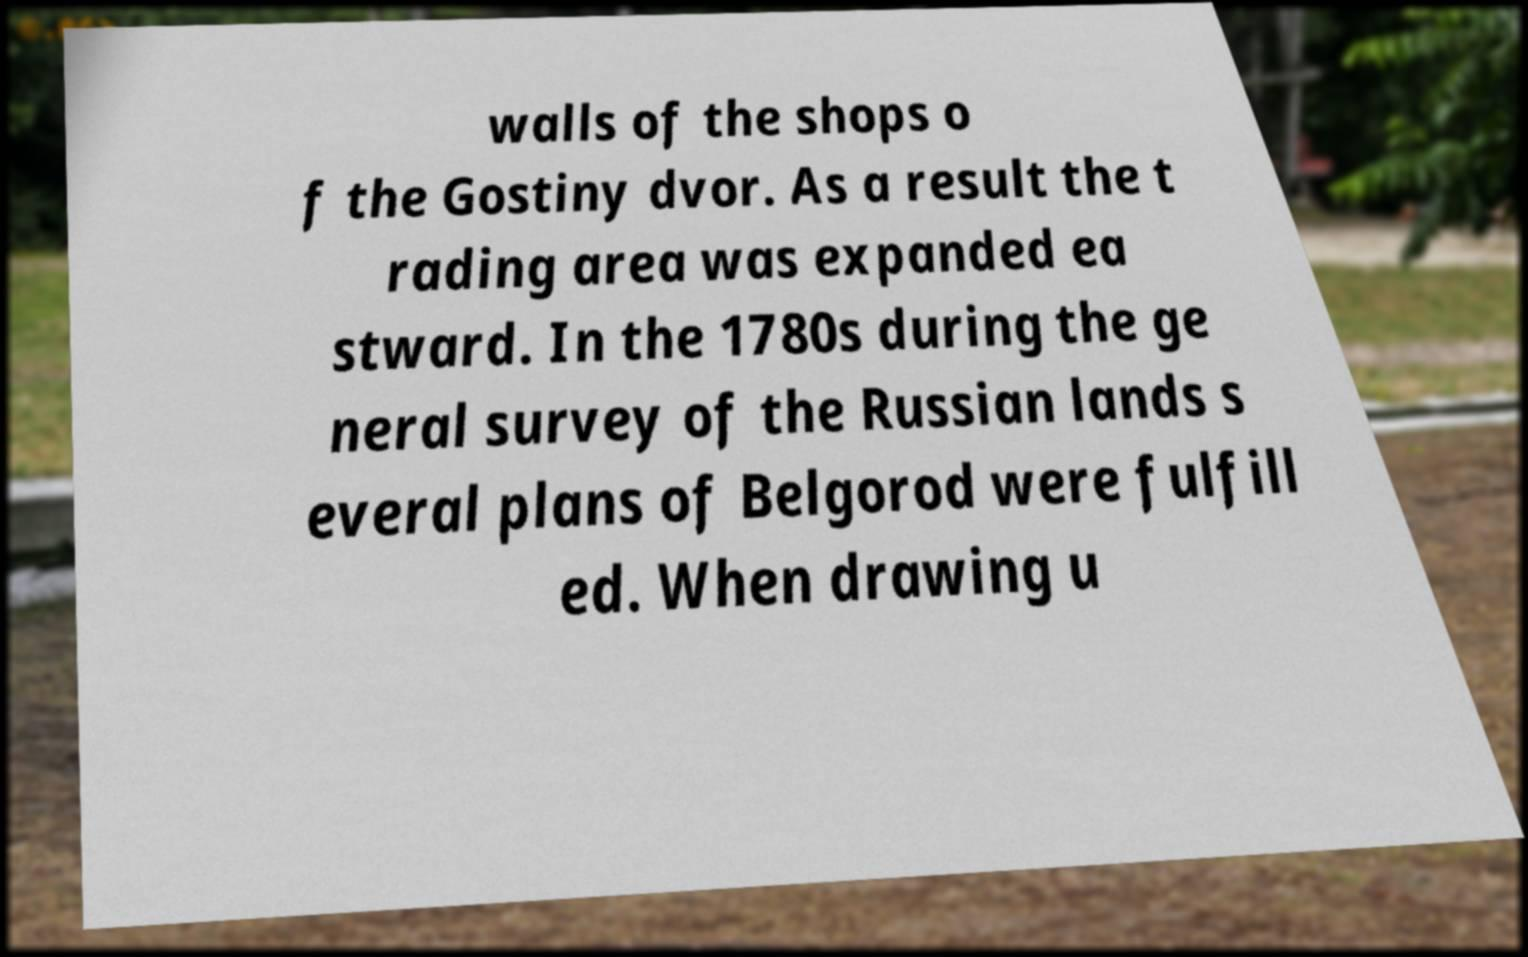Could you extract and type out the text from this image? walls of the shops o f the Gostiny dvor. As a result the t rading area was expanded ea stward. In the 1780s during the ge neral survey of the Russian lands s everal plans of Belgorod were fulfill ed. When drawing u 